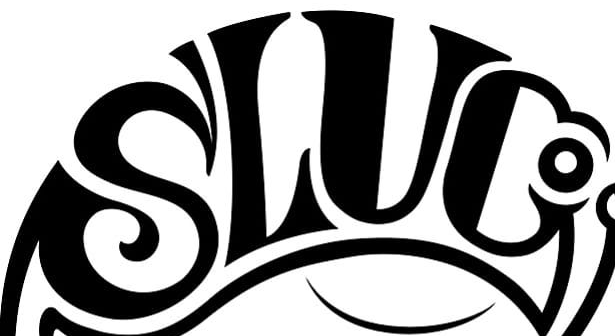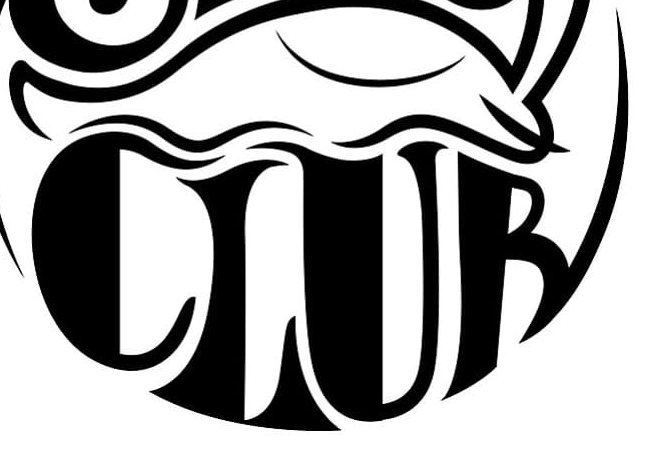Read the text content from these images in order, separated by a semicolon. SLUC; CLUB 